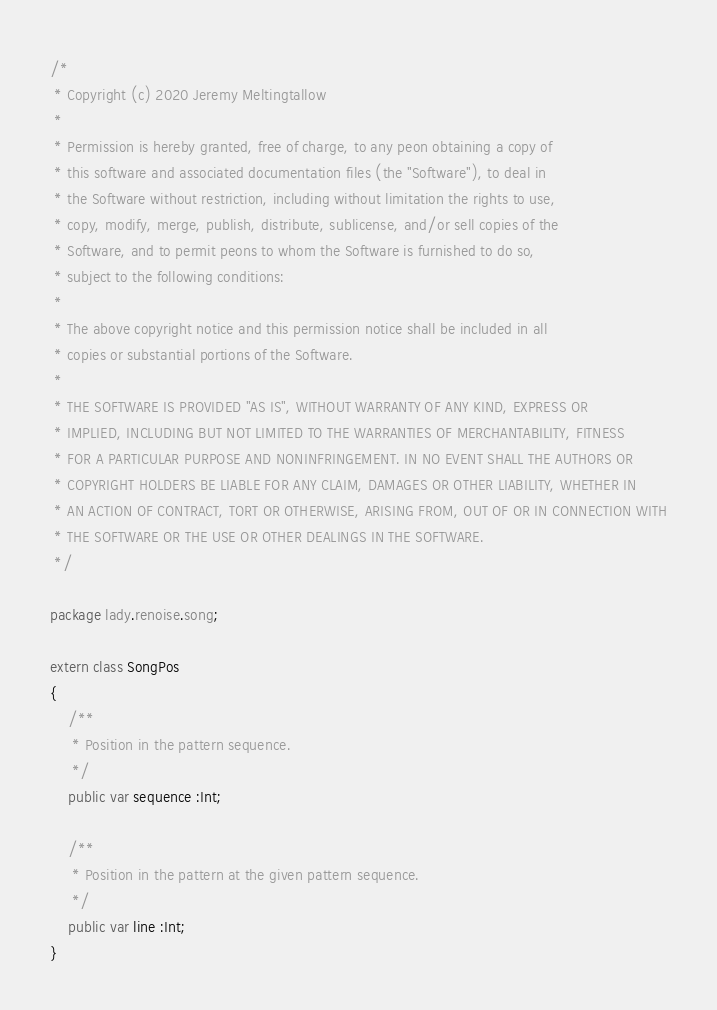Convert code to text. <code><loc_0><loc_0><loc_500><loc_500><_Haxe_>/*
 * Copyright (c) 2020 Jeremy Meltingtallow
 *
 * Permission is hereby granted, free of charge, to any peon obtaining a copy of
 * this software and associated documentation files (the "Software"), to deal in
 * the Software without restriction, including without limitation the rights to use,
 * copy, modify, merge, publish, distribute, sublicense, and/or sell copies of the
 * Software, and to permit peons to whom the Software is furnished to do so,
 * subject to the following conditions:
 *
 * The above copyright notice and this permission notice shall be included in all
 * copies or substantial portions of the Software.
 *
 * THE SOFTWARE IS PROVIDED "AS IS", WITHOUT WARRANTY OF ANY KIND, EXPRESS OR
 * IMPLIED, INCLUDING BUT NOT LIMITED TO THE WARRANTIES OF MERCHANTABILITY, FITNESS
 * FOR A PARTICULAR PURPOSE AND NONINFRINGEMENT. IN NO EVENT SHALL THE AUTHORS OR
 * COPYRIGHT HOLDERS BE LIABLE FOR ANY CLAIM, DAMAGES OR OTHER LIABILITY, WHETHER IN
 * AN ACTION OF CONTRACT, TORT OR OTHERWISE, ARISING FROM, OUT OF OR IN CONNECTION WITH
 * THE SOFTWARE OR THE USE OR OTHER DEALINGS IN THE SOFTWARE.
 */

package lady.renoise.song;

extern class SongPos
{
    /**
     * Position in the pattern sequence.
     */
    public var sequence :Int;

    /**
     * Position in the pattern at the given pattern sequence.
     */
    public var line :Int;
}</code> 